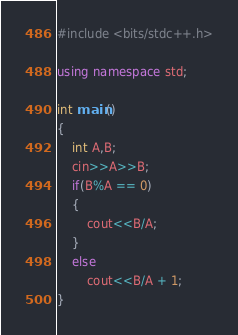Convert code to text. <code><loc_0><loc_0><loc_500><loc_500><_C++_>#include <bits/stdc++.h>

using namespace std;

int main()
{
	int A,B;
	cin>>A>>B;
	if(B%A == 0)
	{
		cout<<B/A;
	}
	else
		cout<<B/A + 1;
}</code> 